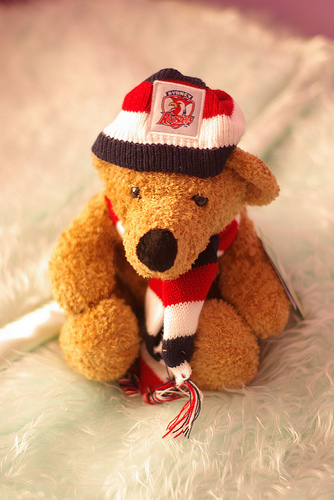<image>
Can you confirm if the cap is on the doll? Yes. Looking at the image, I can see the cap is positioned on top of the doll, with the doll providing support. Is the hat on the blanket? No. The hat is not positioned on the blanket. They may be near each other, but the hat is not supported by or resting on top of the blanket. 